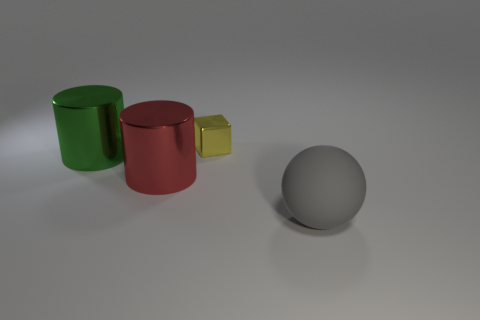Add 4 big purple metallic balls. How many objects exist? 8 Add 4 gray matte things. How many gray matte things are left? 5 Add 4 green objects. How many green objects exist? 5 Subtract 1 yellow cubes. How many objects are left? 3 Subtract all large red objects. Subtract all red metallic cylinders. How many objects are left? 2 